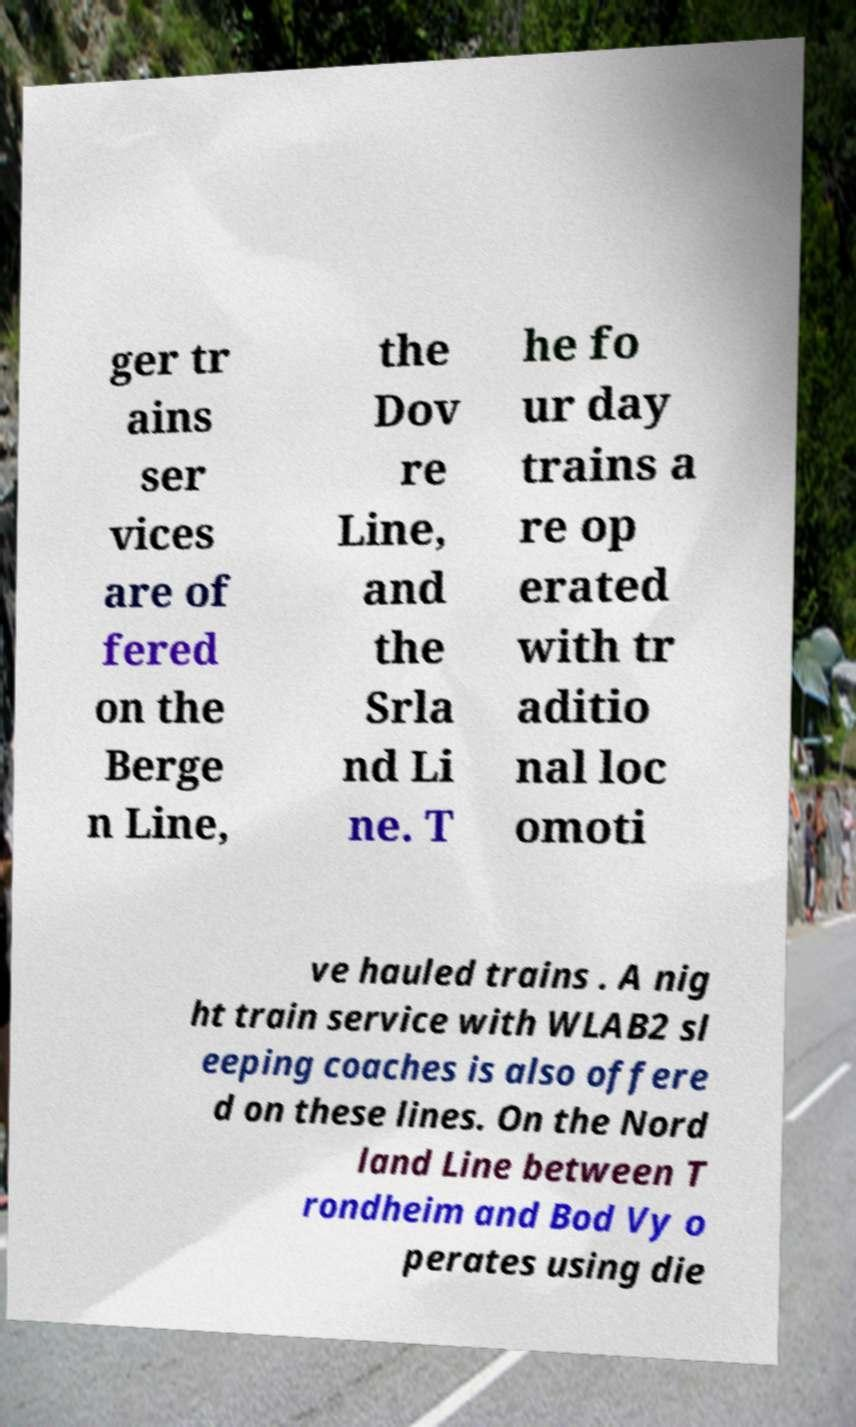What messages or text are displayed in this image? I need them in a readable, typed format. ger tr ains ser vices are of fered on the Berge n Line, the Dov re Line, and the Srla nd Li ne. T he fo ur day trains a re op erated with tr aditio nal loc omoti ve hauled trains . A nig ht train service with WLAB2 sl eeping coaches is also offere d on these lines. On the Nord land Line between T rondheim and Bod Vy o perates using die 